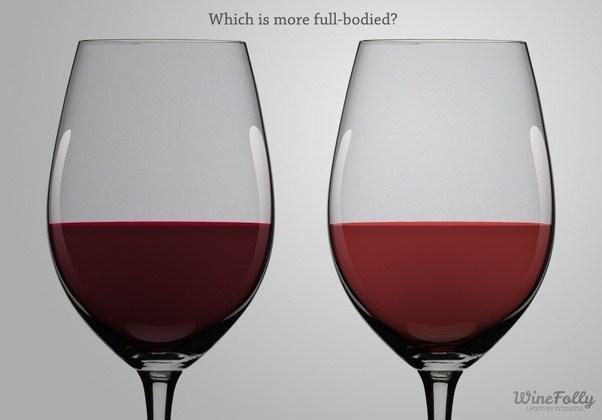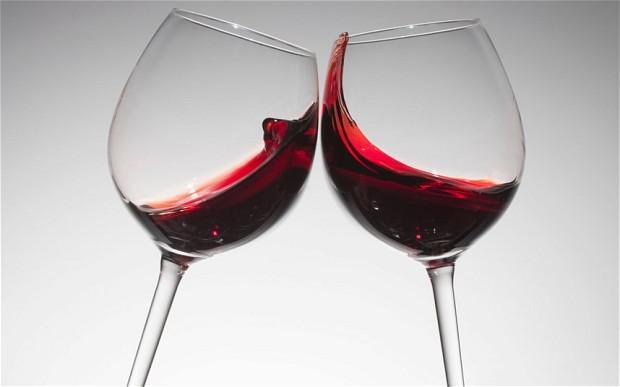The first image is the image on the left, the second image is the image on the right. Given the left and right images, does the statement "The wineglass in the image on the right appears to have a point at its base." hold true? Answer yes or no. No. 